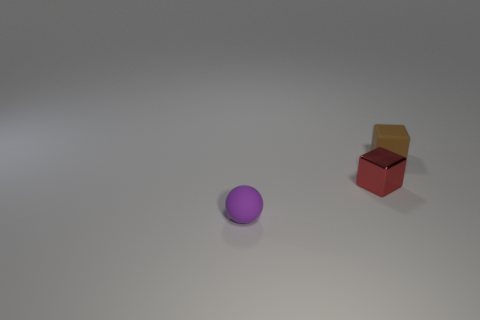Add 3 small gray cubes. How many objects exist? 6 Subtract all spheres. How many objects are left? 2 Add 1 tiny red metallic things. How many tiny red metallic things exist? 2 Subtract 0 gray balls. How many objects are left? 3 Subtract all rubber balls. Subtract all purple rubber things. How many objects are left? 1 Add 1 red metallic blocks. How many red metallic blocks are left? 2 